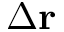<formula> <loc_0><loc_0><loc_500><loc_500>\Delta r</formula> 